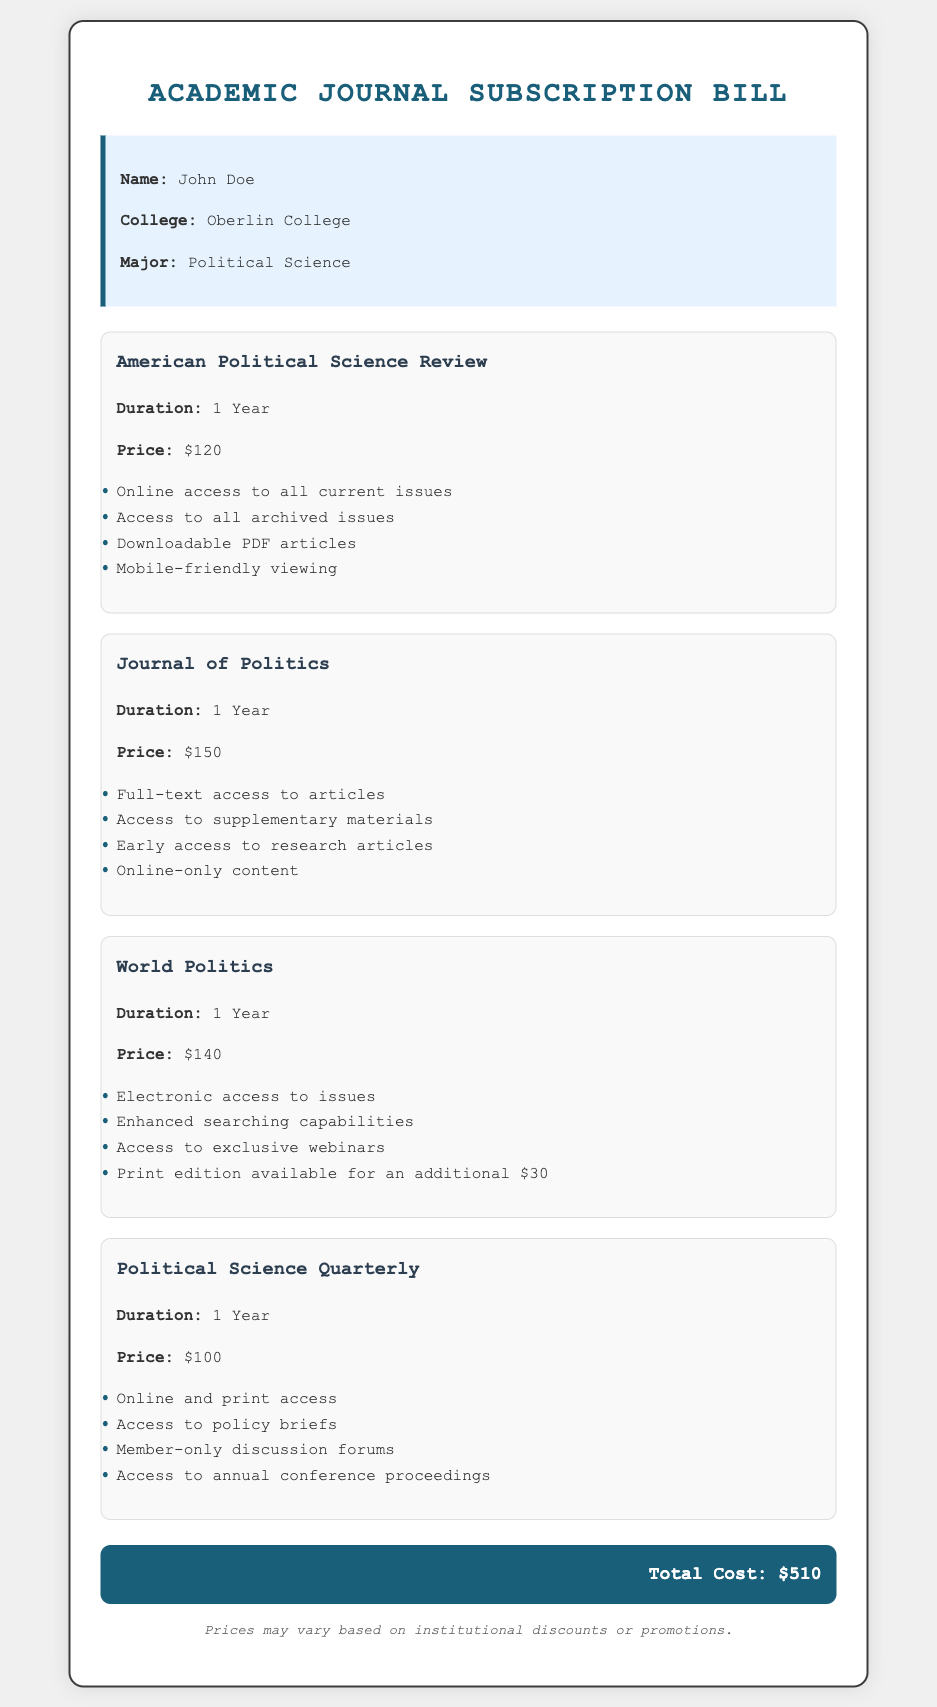What is the duration for the American Political Science Review? The duration for the American Political Science Review is stated clearly in the document under its details.
Answer: 1 Year What is the price for the Journal of Politics? The price for the Journal of Politics can be found in the pricing section of the document.
Answer: $150 What special access feature is offered by World Politics? The document lists several special access features for World Politics, including exclusive webinars.
Answer: Access to exclusive webinars How much is the print edition of World Politics if opted for? The additional cost for the print edition of World Politics is specified in its features list within the document.
Answer: $30 What is the total cost of all subscriptions? The total cost is summarized at the end of the document, reflecting the sum of all individual journal prices.
Answer: $510 Which journal provides access to policy briefs? The document includes details for each journal, indicating which offers specific access features, like policy briefs.
Answer: Political Science Quarterly How many journals are listed in the document? By counting the individual journal sections in the document, the total number can be easily determined.
Answer: 4 